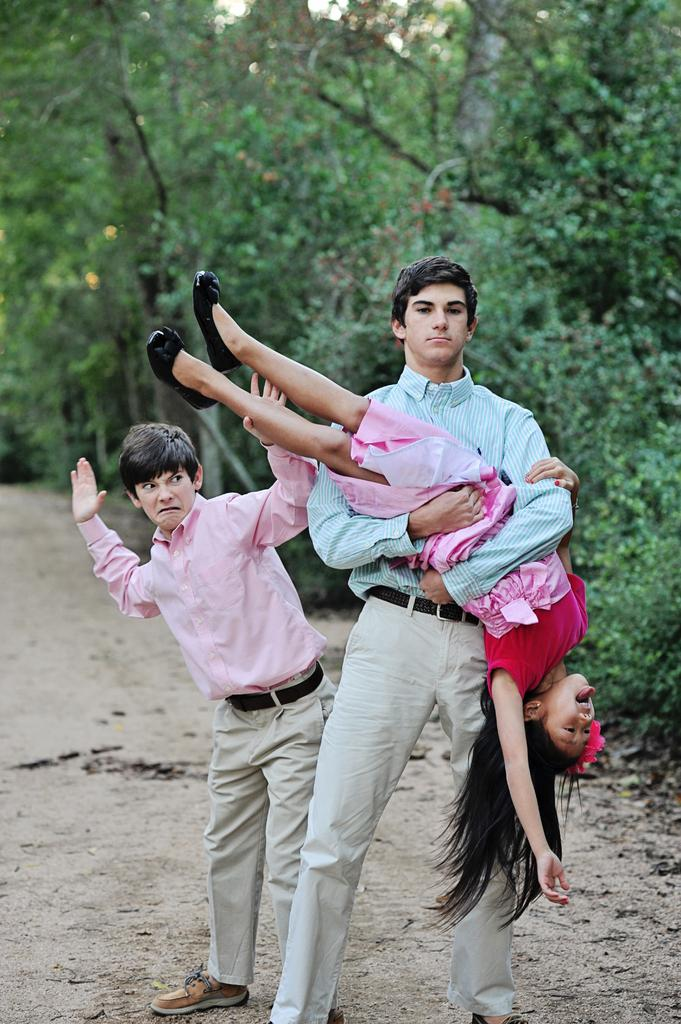How many people are in the image? There are two persons standing on the ground. What is the man doing in the image? A man is holding a girl. What can be seen in the background of the image? There are trees visible behind the three persons. What type of sink can be seen in the image? There is no sink present in the image. How many bushes are visible in the image? There is no mention of bushes in the image; only trees are visible in the background. 